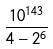Convert formula to latex. <formula><loc_0><loc_0><loc_500><loc_500>\frac { 1 0 ^ { 1 4 3 } } { 4 - 2 ^ { 6 } }</formula> 